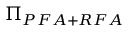<formula> <loc_0><loc_0><loc_500><loc_500>\Pi _ { P F A + R F A }</formula> 